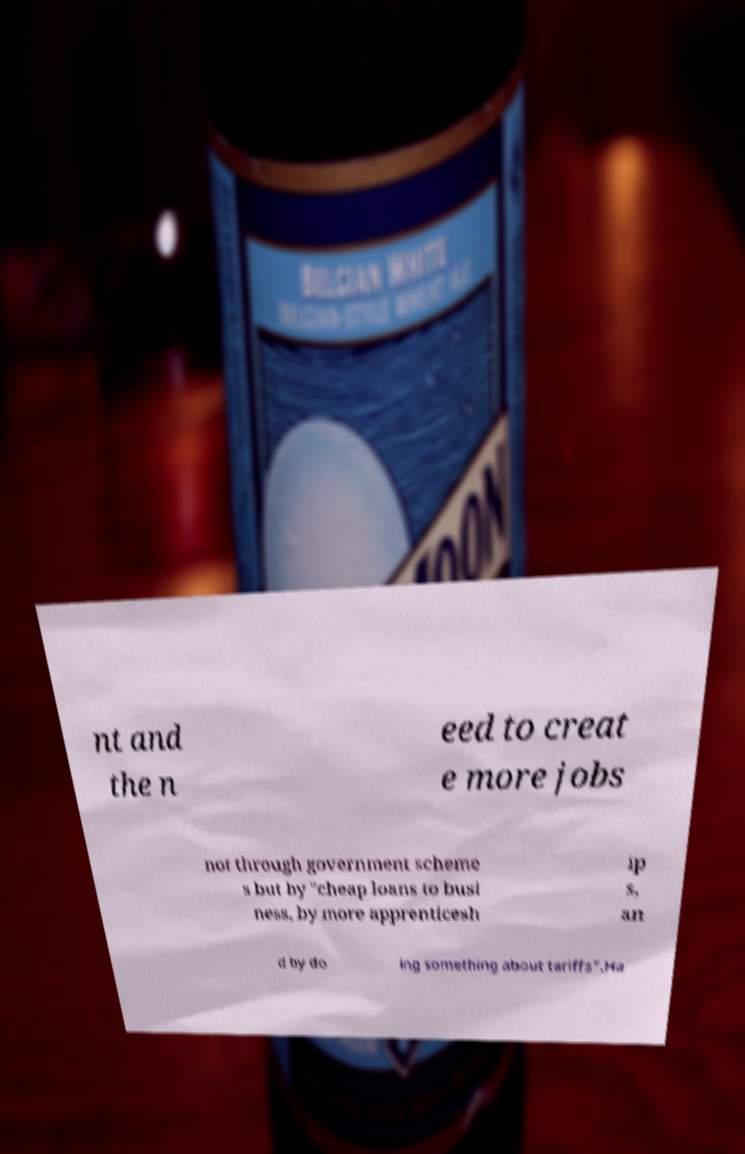Could you extract and type out the text from this image? nt and the n eed to creat e more jobs not through government scheme s but by "cheap loans to busi ness, by more apprenticesh ip s, an d by do ing something about tariffs".Ha 